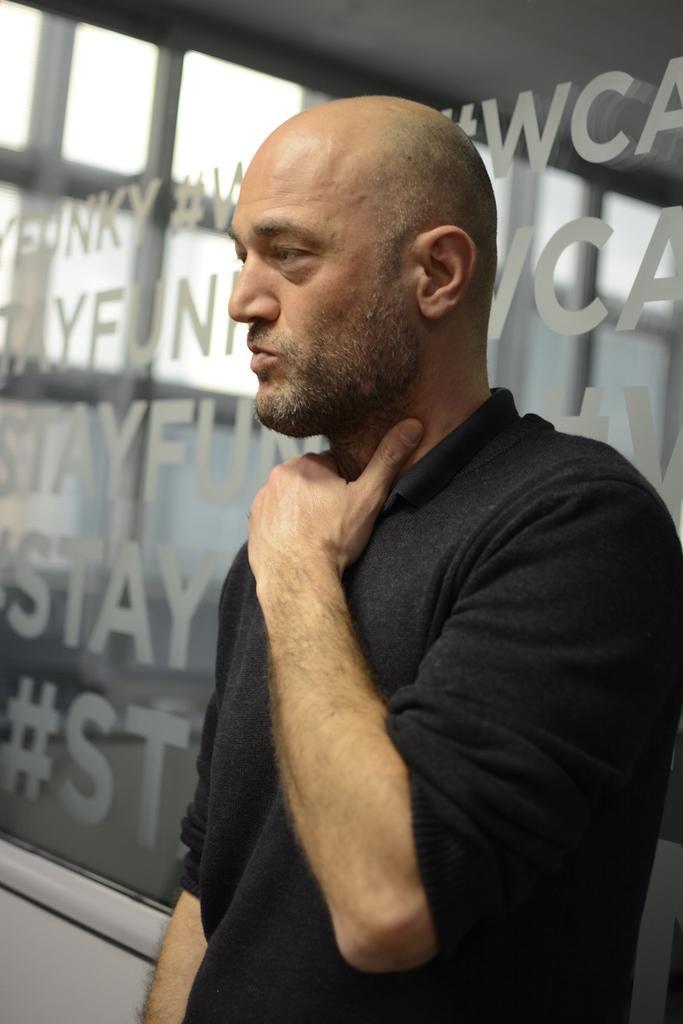Can you describe this image briefly? In the center of the image we can see one person is standing and he is in a black t shirt. In the background there is a wall, roof and glass. And we can see some text on the glass. 